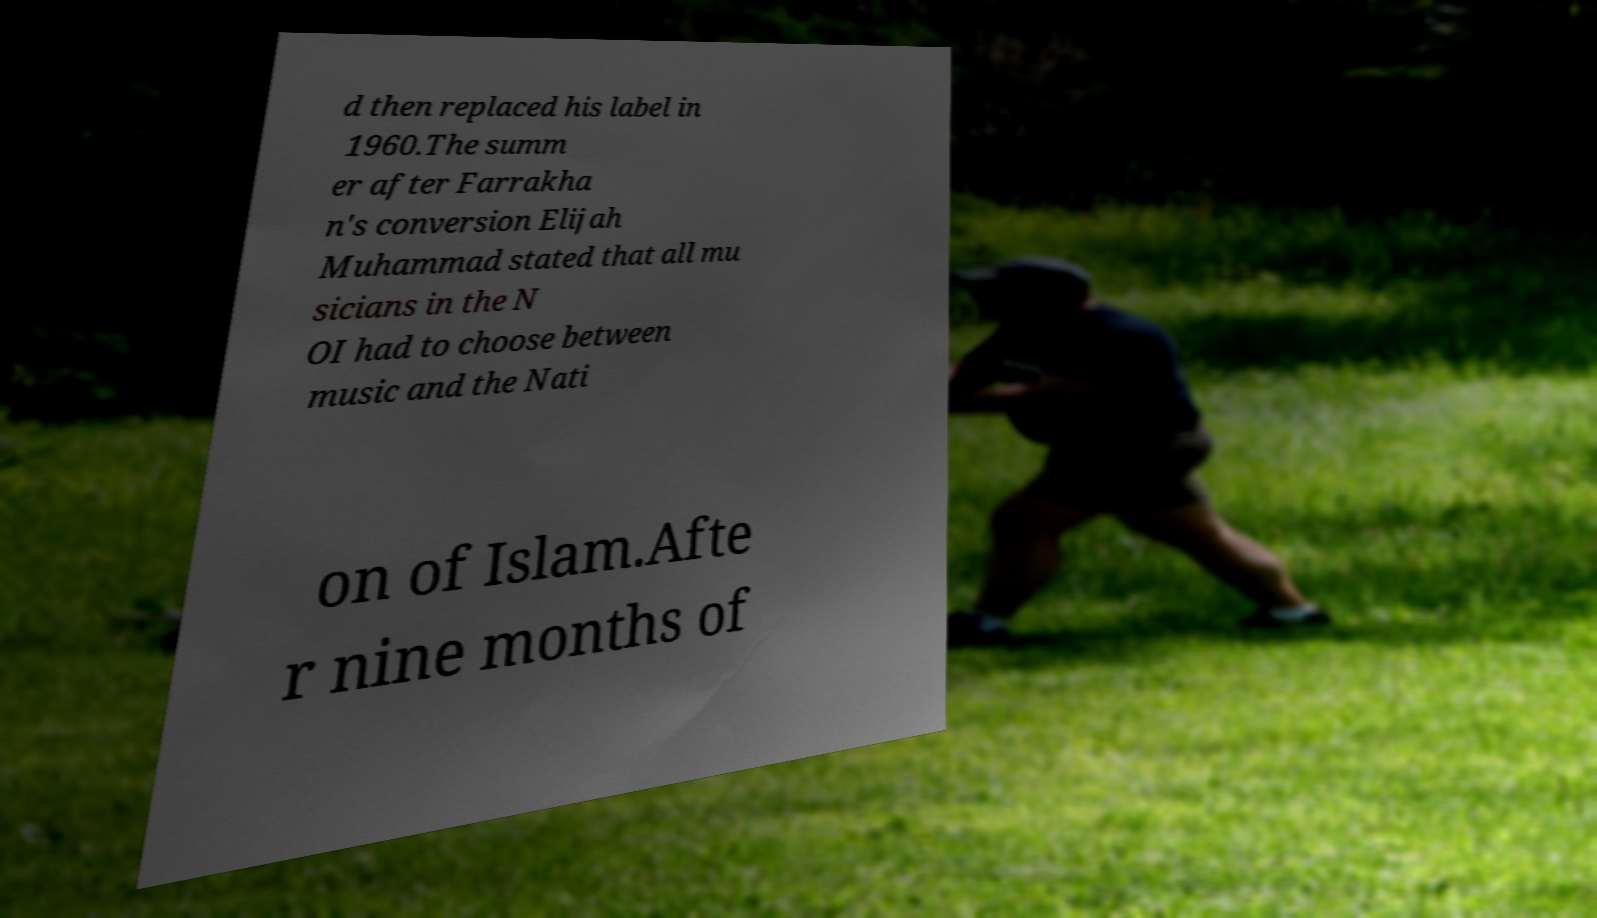Can you read and provide the text displayed in the image?This photo seems to have some interesting text. Can you extract and type it out for me? d then replaced his label in 1960.The summ er after Farrakha n's conversion Elijah Muhammad stated that all mu sicians in the N OI had to choose between music and the Nati on of Islam.Afte r nine months of 